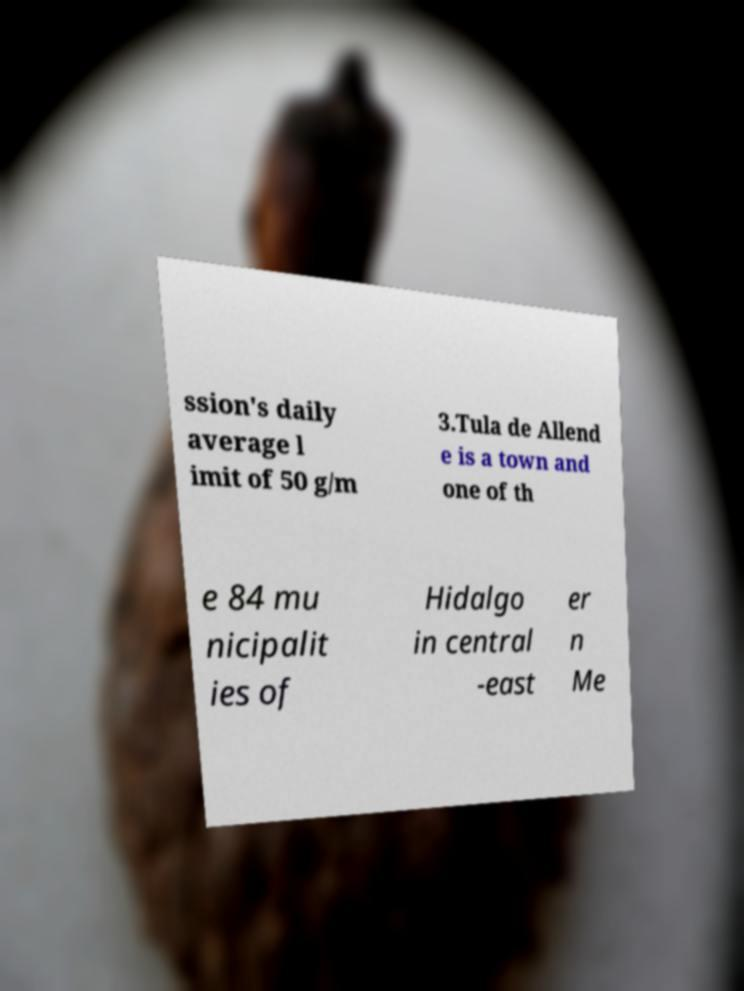Can you read and provide the text displayed in the image?This photo seems to have some interesting text. Can you extract and type it out for me? ssion's daily average l imit of 50 g/m 3.Tula de Allend e is a town and one of th e 84 mu nicipalit ies of Hidalgo in central -east er n Me 